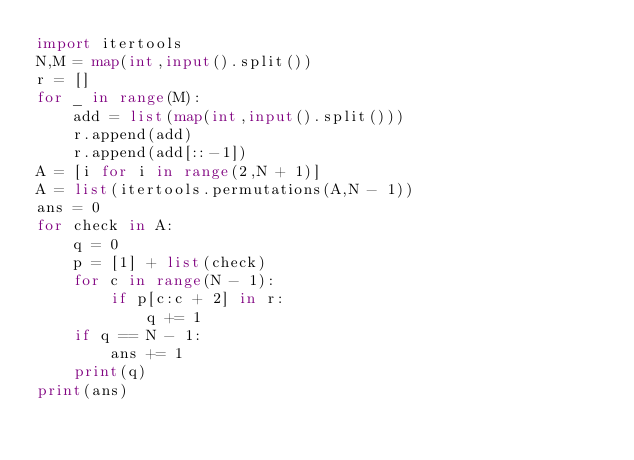<code> <loc_0><loc_0><loc_500><loc_500><_Python_>import itertools
N,M = map(int,input().split())
r = []
for _ in range(M):
    add = list(map(int,input().split()))
    r.append(add)
    r.append(add[::-1])
A = [i for i in range(2,N + 1)]
A = list(itertools.permutations(A,N - 1))
ans = 0
for check in A:
    q = 0
    p = [1] + list(check)
    for c in range(N - 1):
        if p[c:c + 2] in r:
            q += 1
    if q == N - 1:
        ans += 1
    print(q)
print(ans)</code> 